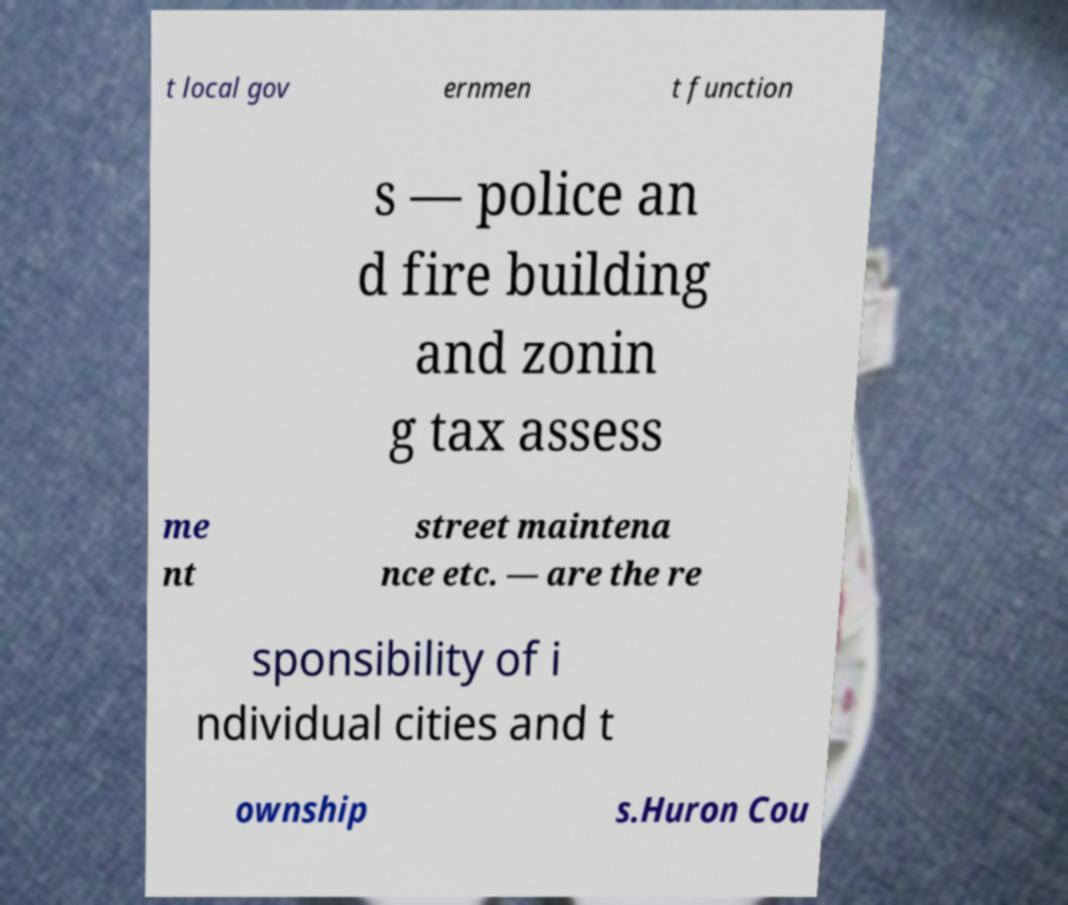There's text embedded in this image that I need extracted. Can you transcribe it verbatim? t local gov ernmen t function s — police an d fire building and zonin g tax assess me nt street maintena nce etc. — are the re sponsibility of i ndividual cities and t ownship s.Huron Cou 